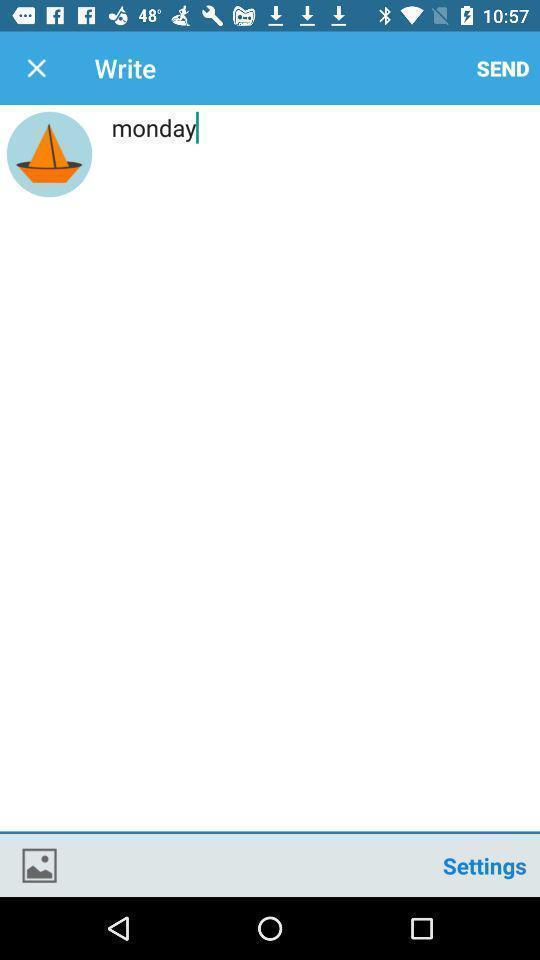Describe the visual elements of this screenshot. Window displaying a message page. 